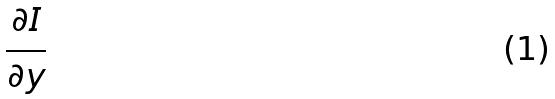Convert formula to latex. <formula><loc_0><loc_0><loc_500><loc_500>\frac { \partial I } { \partial y }</formula> 